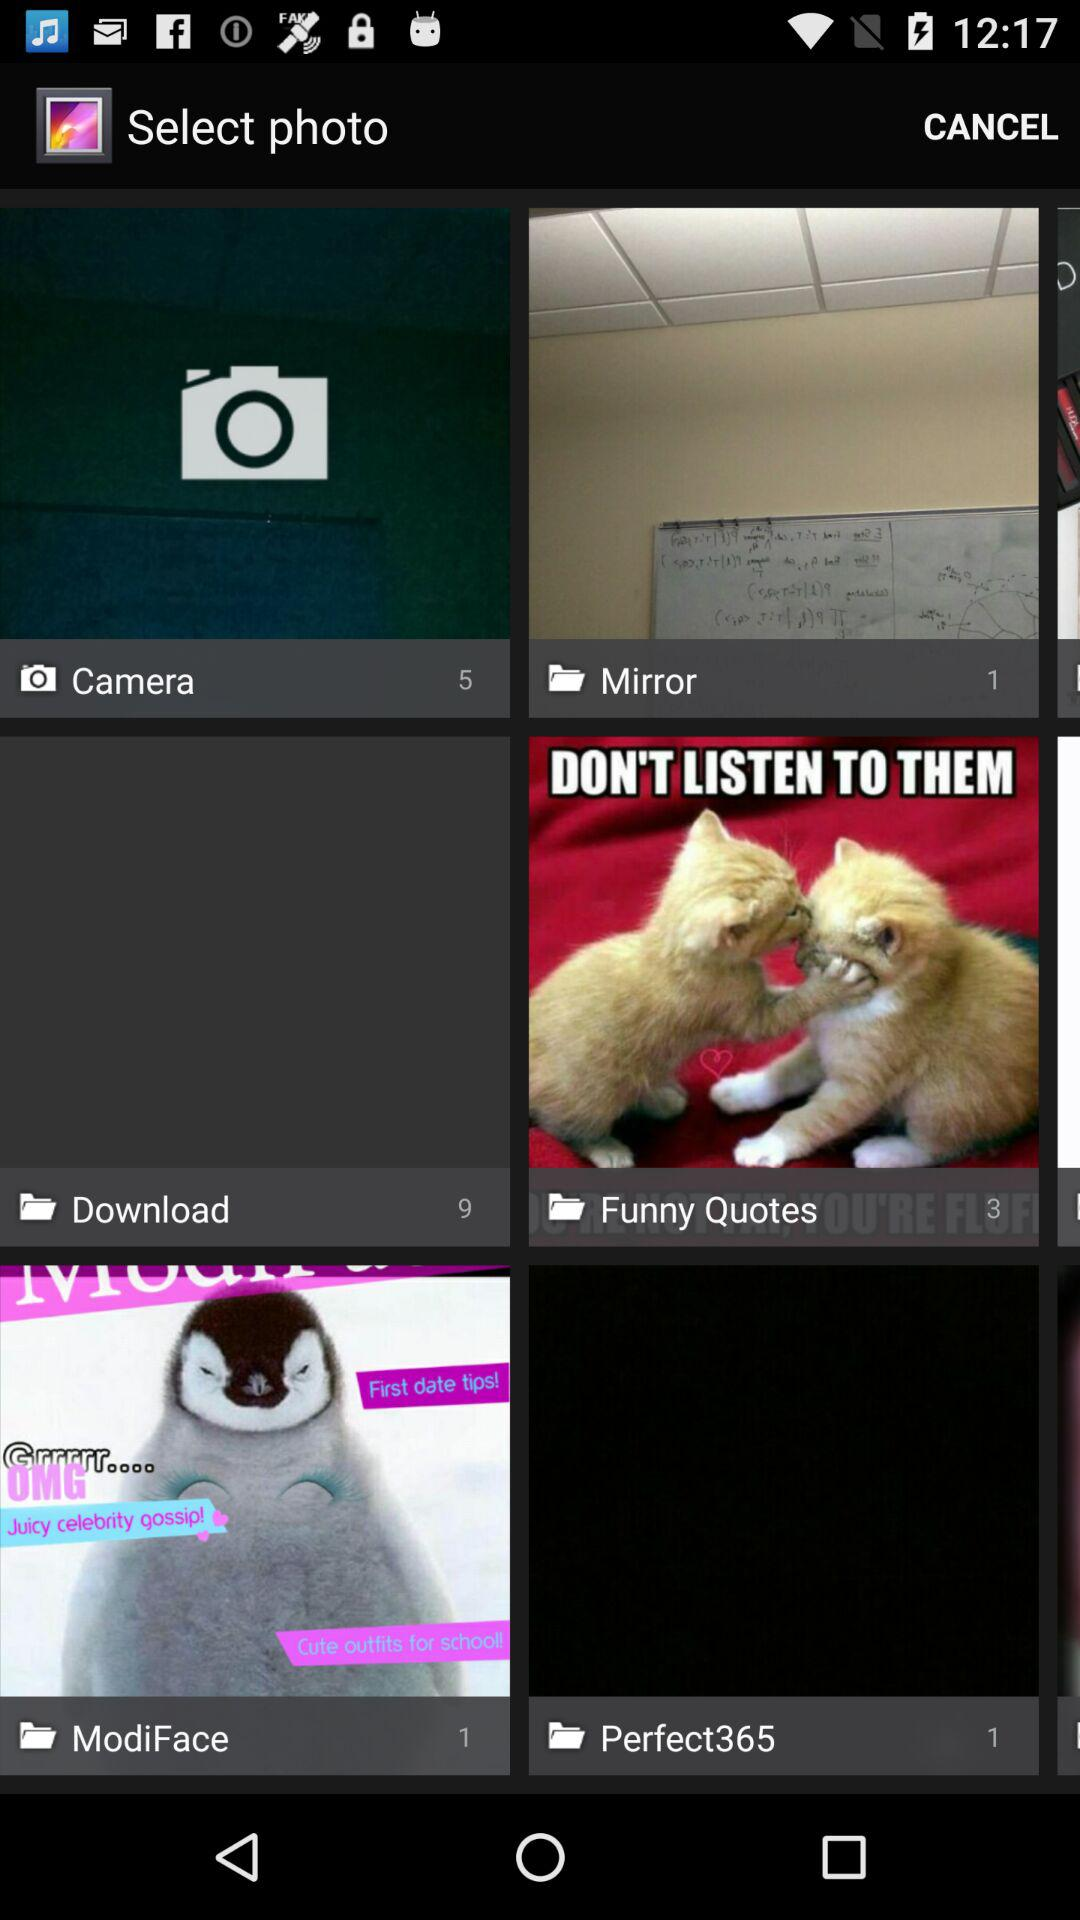The camera folder has how many images? There are 5 images in the camera folder. 